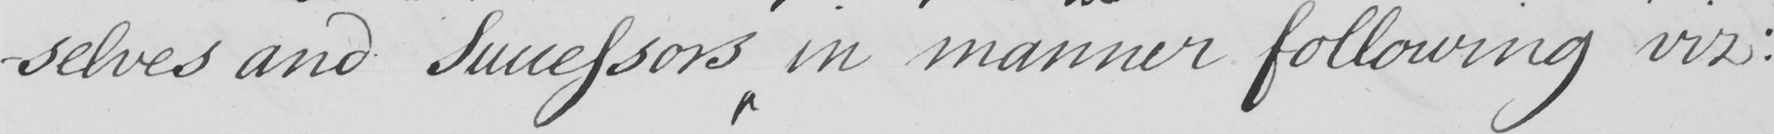What text is written in this handwritten line? selves and Successors in manner following viz : 